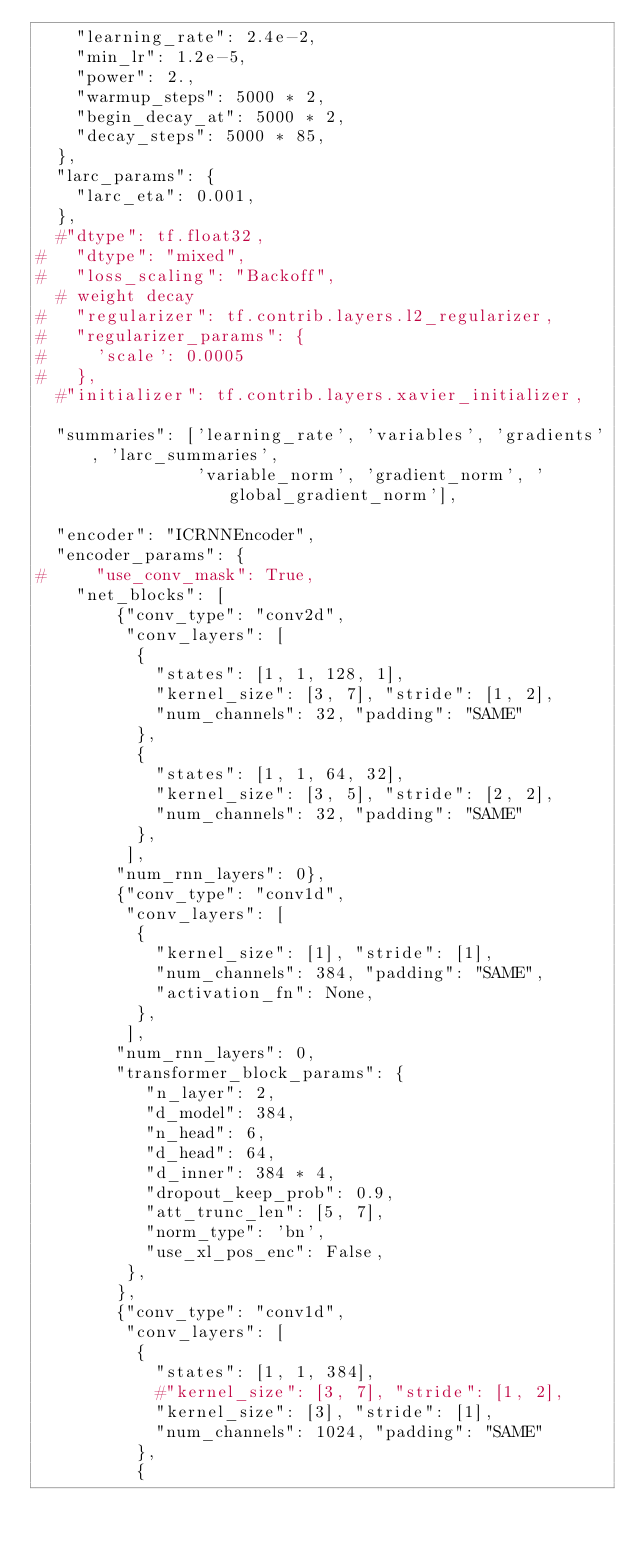<code> <loc_0><loc_0><loc_500><loc_500><_Python_>    "learning_rate": 2.4e-2,
    "min_lr": 1.2e-5,
    "power": 2.,
    "warmup_steps": 5000 * 2,
    "begin_decay_at": 5000 * 2,
    "decay_steps": 5000 * 85,
  },
  "larc_params": {
    "larc_eta": 0.001,
  },
  #"dtype": tf.float32,
#   "dtype": "mixed",
#   "loss_scaling": "Backoff",
  # weight decay
#   "regularizer": tf.contrib.layers.l2_regularizer,
#   "regularizer_params": {
#     'scale': 0.0005
#   },
  #"initializer": tf.contrib.layers.xavier_initializer,

  "summaries": ['learning_rate', 'variables', 'gradients', 'larc_summaries',
                'variable_norm', 'gradient_norm', 'global_gradient_norm'],

  "encoder": "ICRNNEncoder",
  "encoder_params": {
#     "use_conv_mask": True,
    "net_blocks": [
        {"conv_type": "conv2d",
         "conv_layers": [
          {
            "states": [1, 1, 128, 1],
            "kernel_size": [3, 7], "stride": [1, 2],
            "num_channels": 32, "padding": "SAME"
          },
          {
            "states": [1, 1, 64, 32],
            "kernel_size": [3, 5], "stride": [2, 2],
            "num_channels": 32, "padding": "SAME"
          },
         ],
        "num_rnn_layers": 0},
        {"conv_type": "conv1d",
         "conv_layers": [
          {
            "kernel_size": [1], "stride": [1],
            "num_channels": 384, "padding": "SAME",
            "activation_fn": None,
          },
         ],
        "num_rnn_layers": 0,
        "transformer_block_params": {
           "n_layer": 2,
           "d_model": 384,
           "n_head": 6,
           "d_head": 64,
           "d_inner": 384 * 4,
           "dropout_keep_prob": 0.9,
           "att_trunc_len": [5, 7],
           "norm_type": 'bn',
           "use_xl_pos_enc": False,
         },
        },
        {"conv_type": "conv1d",
         "conv_layers": [
          {
            "states": [1, 1, 384],
            #"kernel_size": [3, 7], "stride": [1, 2],
            "kernel_size": [3], "stride": [1],
            "num_channels": 1024, "padding": "SAME"
          },
          {</code> 